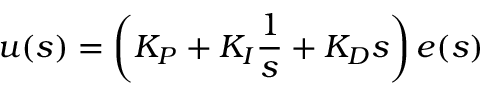<formula> <loc_0><loc_0><loc_500><loc_500>u ( s ) = \left ( K _ { P } + K _ { I } { \frac { 1 } { s } } + K _ { D } s \right ) e ( s )</formula> 